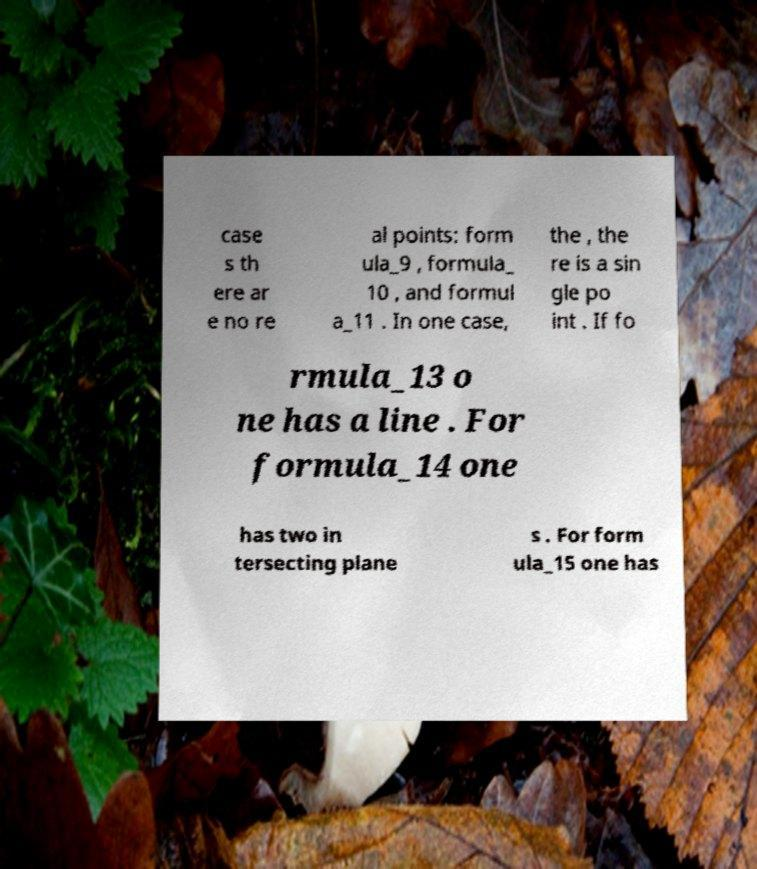Can you accurately transcribe the text from the provided image for me? case s th ere ar e no re al points: form ula_9 , formula_ 10 , and formul a_11 . In one case, the , the re is a sin gle po int . If fo rmula_13 o ne has a line . For formula_14 one has two in tersecting plane s . For form ula_15 one has 